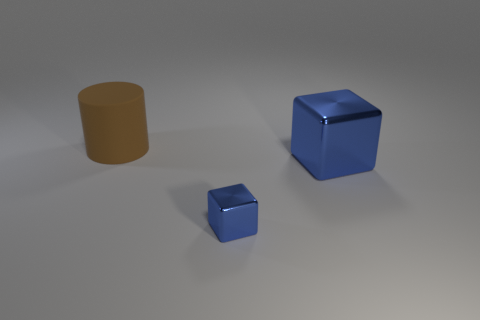Add 1 big gray blocks. How many objects exist? 4 Subtract all blocks. How many objects are left? 1 Subtract all blue matte cylinders. Subtract all large blue metal things. How many objects are left? 2 Add 3 large brown rubber things. How many large brown rubber things are left? 4 Add 1 small blue objects. How many small blue objects exist? 2 Subtract 2 blue cubes. How many objects are left? 1 